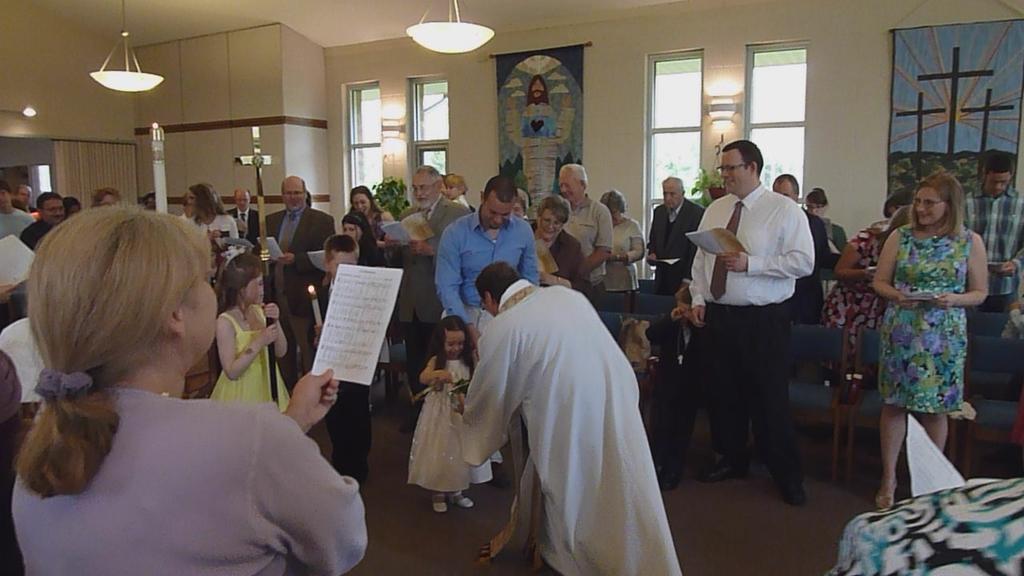How would you summarize this image in a sentence or two? In this picture we can see a group of people on the ground, some people are holding papers, here we can see a candle, chairs and some objects and in the background we can see a wall, windows, lights, posters, roof and some objects. 